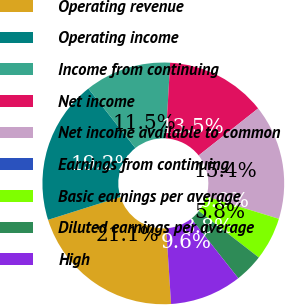Convert chart. <chart><loc_0><loc_0><loc_500><loc_500><pie_chart><fcel>Operating revenue<fcel>Operating income<fcel>Income from continuing<fcel>Net income<fcel>Net income available to common<fcel>Earnings from continuing<fcel>Basic earnings per average<fcel>Diluted earnings per average<fcel>High<nl><fcel>21.15%<fcel>19.23%<fcel>11.54%<fcel>13.46%<fcel>15.38%<fcel>0.0%<fcel>5.77%<fcel>3.85%<fcel>9.62%<nl></chart> 